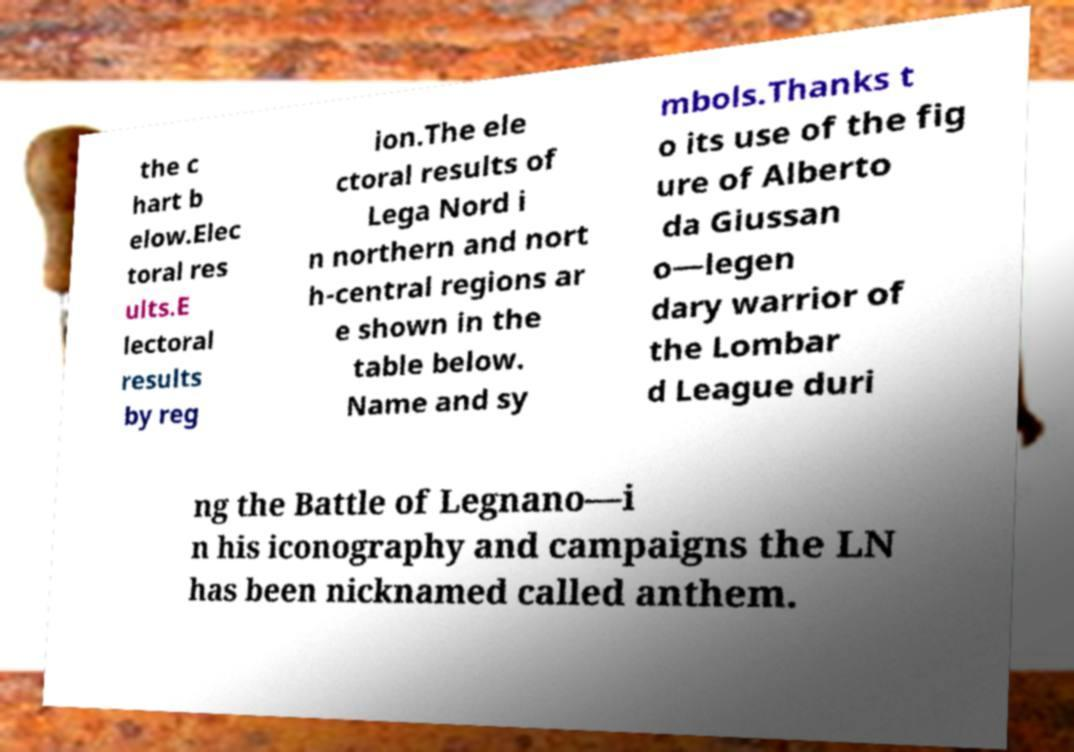Please identify and transcribe the text found in this image. the c hart b elow.Elec toral res ults.E lectoral results by reg ion.The ele ctoral results of Lega Nord i n northern and nort h-central regions ar e shown in the table below. Name and sy mbols.Thanks t o its use of the fig ure of Alberto da Giussan o—legen dary warrior of the Lombar d League duri ng the Battle of Legnano—i n his iconography and campaigns the LN has been nicknamed called anthem. 